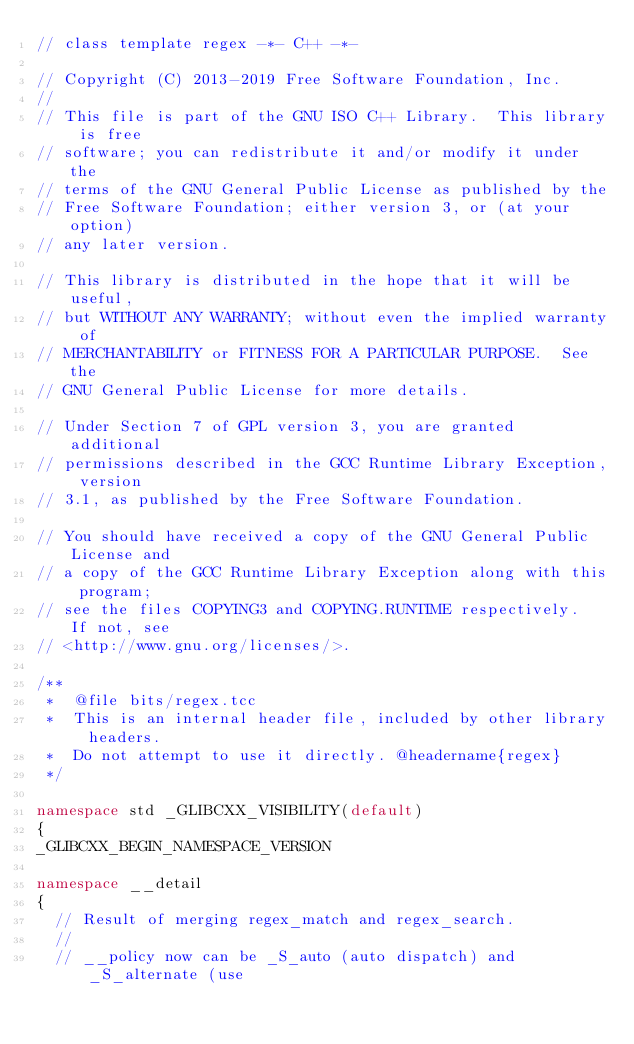Convert code to text. <code><loc_0><loc_0><loc_500><loc_500><_C++_>// class template regex -*- C++ -*-

// Copyright (C) 2013-2019 Free Software Foundation, Inc.
//
// This file is part of the GNU ISO C++ Library.  This library is free
// software; you can redistribute it and/or modify it under the
// terms of the GNU General Public License as published by the
// Free Software Foundation; either version 3, or (at your option)
// any later version.

// This library is distributed in the hope that it will be useful,
// but WITHOUT ANY WARRANTY; without even the implied warranty of
// MERCHANTABILITY or FITNESS FOR A PARTICULAR PURPOSE.  See the
// GNU General Public License for more details.

// Under Section 7 of GPL version 3, you are granted additional
// permissions described in the GCC Runtime Library Exception, version
// 3.1, as published by the Free Software Foundation.

// You should have received a copy of the GNU General Public License and
// a copy of the GCC Runtime Library Exception along with this program;
// see the files COPYING3 and COPYING.RUNTIME respectively.  If not, see
// <http://www.gnu.org/licenses/>.

/**
 *  @file bits/regex.tcc
 *  This is an internal header file, included by other library headers.
 *  Do not attempt to use it directly. @headername{regex}
 */

namespace std _GLIBCXX_VISIBILITY(default)
{
_GLIBCXX_BEGIN_NAMESPACE_VERSION

namespace __detail
{
  // Result of merging regex_match and regex_search.
  //
  // __policy now can be _S_auto (auto dispatch) and _S_alternate (use</code> 